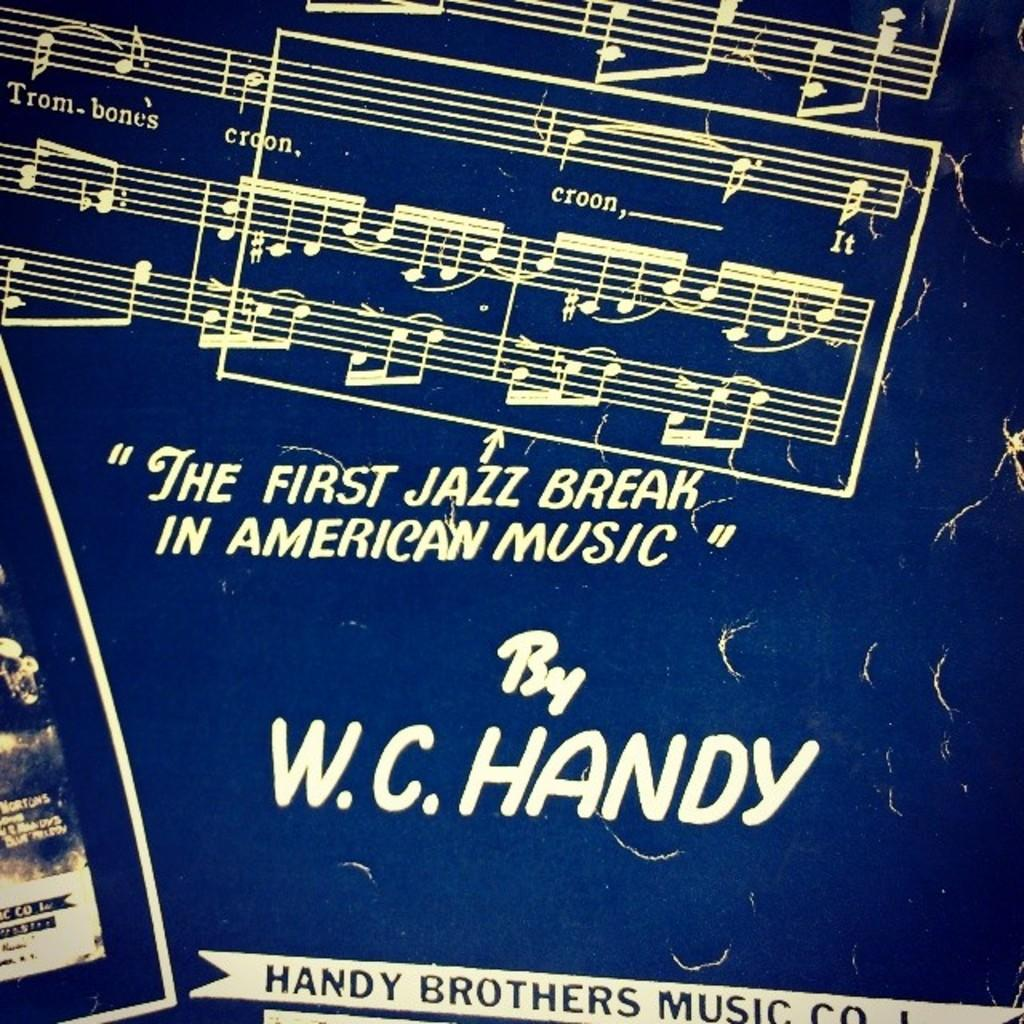<image>
Give a short and clear explanation of the subsequent image. A rectangle marks what is described as the first jazz break in American music. 